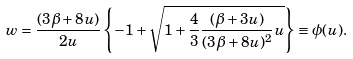Convert formula to latex. <formula><loc_0><loc_0><loc_500><loc_500>w = \frac { ( 3 \beta + 8 u ) } { 2 u } \left \{ - 1 + \sqrt { 1 + \frac { 4 } { 3 } \frac { ( \beta + 3 u ) } { ( 3 \beta + 8 u ) ^ { 2 } } u } \right \} \equiv \phi ( u ) .</formula> 